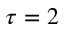Convert formula to latex. <formula><loc_0><loc_0><loc_500><loc_500>\tau = 2</formula> 